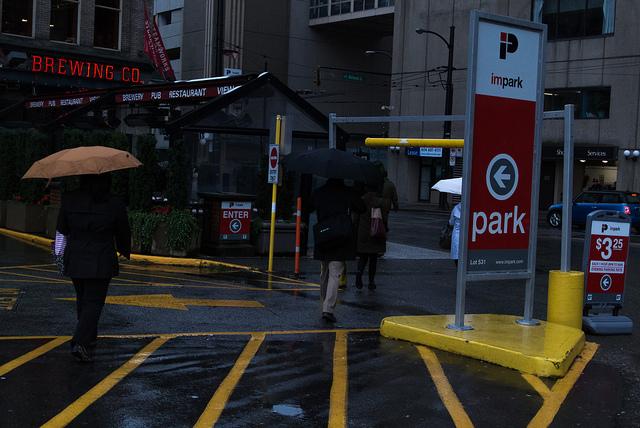How much does parking cost?
Give a very brief answer. 3.25. What colors are the arrows?
Write a very short answer. White. Where is the company sign?
Short answer required. On building. Where are the people walking in the picture?
Keep it brief. Street. Which direction is the parking?
Short answer required. Left. What letter is on the sign near the top of the picture?
Give a very brief answer. P. How can we tell it must be a rainy day?
Give a very brief answer. Umbrellas. Does the sign indicate it's safe to walk?
Quick response, please. No. Who is walking in the street?
Be succinct. People. 